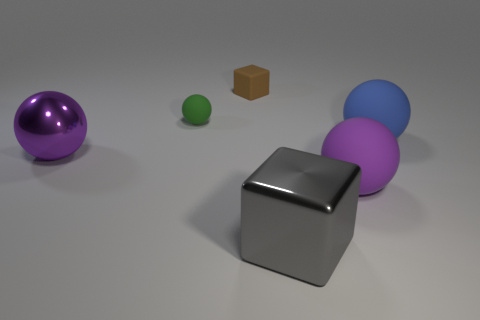Subtract all yellow blocks. Subtract all purple cylinders. How many blocks are left? 2 Subtract all green cylinders. How many cyan blocks are left? 0 Add 4 grays. How many big purples exist? 0 Subtract all purple metallic balls. Subtract all tiny red objects. How many objects are left? 5 Add 1 brown rubber things. How many brown rubber things are left? 2 Add 2 large balls. How many large balls exist? 5 Add 1 large cyan spheres. How many objects exist? 7 Subtract all gray cubes. How many cubes are left? 1 Subtract all metal spheres. How many spheres are left? 3 Subtract 0 red spheres. How many objects are left? 6 